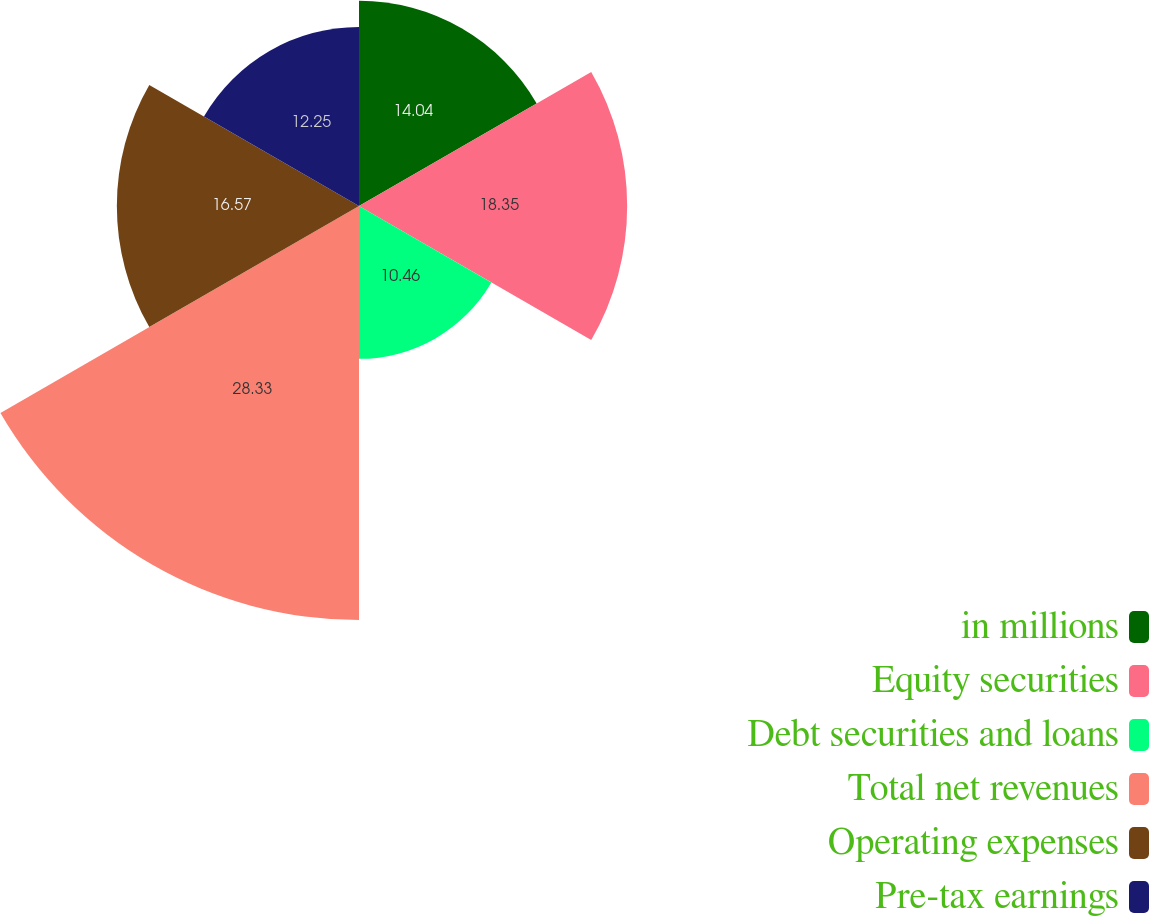<chart> <loc_0><loc_0><loc_500><loc_500><pie_chart><fcel>in millions<fcel>Equity securities<fcel>Debt securities and loans<fcel>Total net revenues<fcel>Operating expenses<fcel>Pre-tax earnings<nl><fcel>14.04%<fcel>18.35%<fcel>10.46%<fcel>28.33%<fcel>16.57%<fcel>12.25%<nl></chart> 